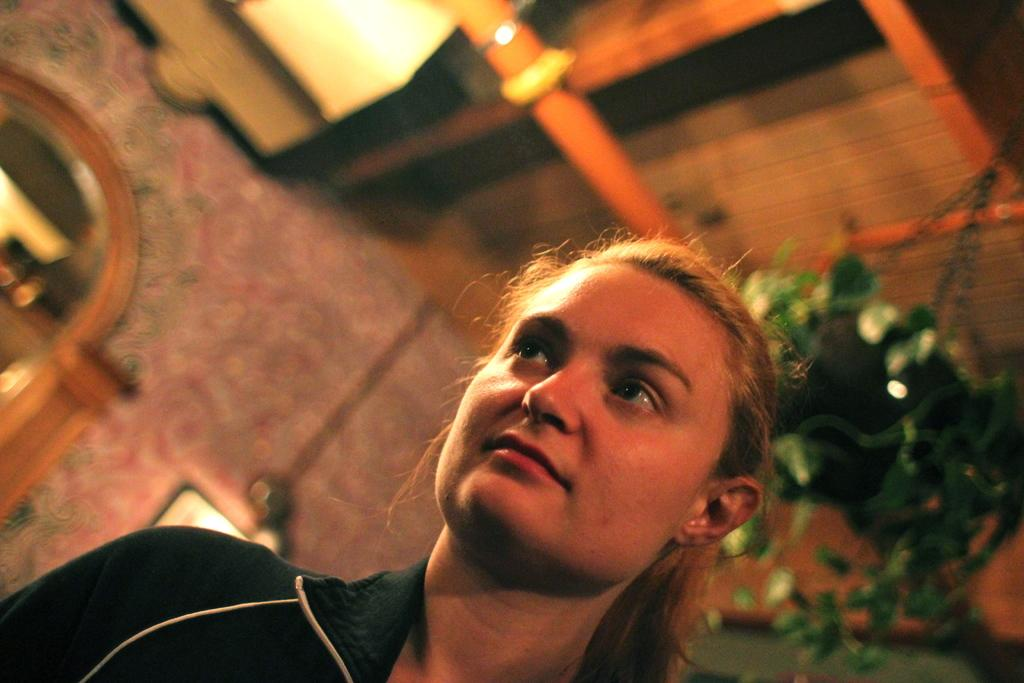Who is the main subject in the image? There is a girl in the image. What is the girl wearing? The girl is wearing clothes. What is the girl doing in the image? The girl is standing. Can you describe the background of the image? The background of the image is blurred. How many men are visible in the image? There are no men present in the image; it features a girl. What type of wall can be seen in the image? There is no wall present in the image. 